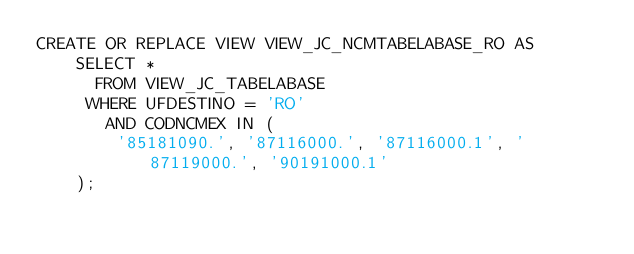Convert code to text. <code><loc_0><loc_0><loc_500><loc_500><_SQL_>CREATE OR REPLACE VIEW VIEW_JC_NCMTABELABASE_RO AS
    SELECT *
      FROM VIEW_JC_TABELABASE
     WHERE UFDESTINO = 'RO'
       AND CODNCMEX IN (
        '85181090.', '87116000.', '87116000.1', '87119000.', '90191000.1'
    );</code> 